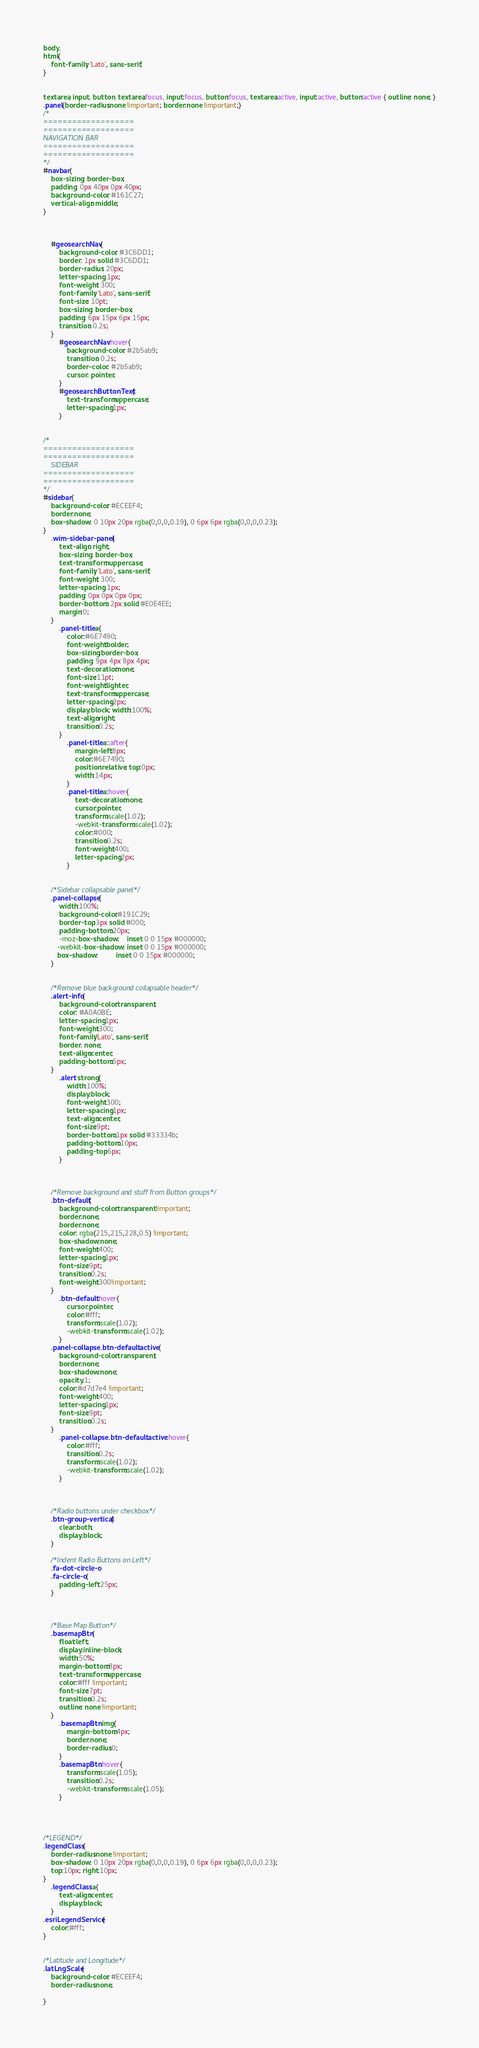<code> <loc_0><loc_0><loc_500><loc_500><_CSS_>body,
html{
    font-family: 'Lato', sans-serif;
}


textarea, input, button, textarea:focus, input:focus, button:focus, textarea:active, input:active, button:active { outline: none; }
.panel{border-radius:none !important; border:none !important;}
/*
===================
===================
NAVIGATION BAR
===================
===================
*/
#navbar{
    box-sizing: border-box;
    padding: 0px 40px 0px 40px;
    background-color: #161C27;
    vertical-align: middle;
}

    

    #geosearchNav{
        background-color: #3C6DD1;
        border: 1px solid #3C6DD1;
        border-radius: 20px;
        letter-spacing: 1px;
        font-weight: 300;
        font-family: 'Lato', sans-serif;
        font-size: 10pt;
        box-sizing: border-box;
        padding: 6px 15px 6px 15px;
        transition: 0.2s;
    }
        #geosearchNav:hover{
            background-color: #2b5ab9;
            transition: 0.2s;
            border-color: #2b5ab9;
            cursor: pointer;
        }
        #geosearchButtonText{
            text-transform:uppercase;
            letter-spacing:1px;
        }


/*
===================
===================
    SIDEBAR
===================
===================
*/
#sidebar{
    background-color: #ECEEF4;
    border:none;
    box-shadow: 0 10px 20px rgba(0,0,0,0.19), 0 6px 6px rgba(0,0,0,0.23);
}
    .wim-sidebar-panel{
        text-align: right;
        box-sizing: border-box;
        text-transform: uppercase;
        font-family: 'Lato', sans-serif;
        font-weight: 300;
        letter-spacing: 1px;
        padding: 0px 0px 0px 0px;
        border-bottom: 2px solid #E0E4EE;
        margin:0;
    }
        .panel-title a{
            color:#6E7490;
            font-weight:bolder;
            box-sizing:border-box;
            padding: 9px 4px 8px 4px;
            text-decoration:none;
            font-size:11pt;
            font-weight:lighter;
            text-transform:uppercase;
            letter-spacing:2px;
            display:block; width:100%;
            text-align:right;
            transition:0.2s;
        }
            .panel-title a::after{
                margin-left:8px;
                color:#6E7490;
                position:relative; top:0px;
                width:14px;
            }
            .panel-title a:hover{
                text-decoration:none;
                cursor:pointer;
                transform:scale(1.02);
                -webkit-transform:scale(1.02);
                color:#000;
                transition:0.2s;
                font-weight:400;
                letter-spacing:2px;
            }


    /*Sidebar collapsable panel*/
    .panel-collapse{
        width:100%;
        background-color:#191C29;
        border-top:3px solid #000;
        padding-bottom:20px;
        -moz-box-shadow:    inset 0 0 15px #000000;
       -webkit-box-shadow: inset 0 0 15px #000000;
       box-shadow:         inset 0 0 15px #000000;
    }


    /*Remove blue background collapsable header*/
    .alert-info{
        background-color:transparent;
        color: #A0A0BE;
        letter-spacing:1px;
        font-weight:300;
        font-family:'Lato', sans-serif;
        border: none;
        text-align:center;
        padding-bottom:5px;
    }
        .alert strong{
            width:100%;
            display:block;
            font-weight:300;
            letter-spacing:1px;
            text-align:center;
            font-size:9pt;
            border-bottom:1px solid #33334b;
            padding-bottom:10px;
            padding-top:6px;
        }



    /*Remove background and stuff from Button groups*/
    .btn-default{
        background-color:transparent !important;
        border:none;
        border:none;
        color: rgba(215,215,228,0.5) !important;
        box-shadow:none;
        font-weight:400;
        letter-spacing:1px;
        font-size:9pt;
        transition:0.2s;
        font-weight:300!important;
    }
        .btn-default:hover{
            cursor:pointer;
            color:#fff;
            transform:scale(1.02);
            -webkit-transform:scale(1.02);
        }
    .panel-collapse .btn-default.active{
        background-color:transparent;
        border:none;
        box-shadow:none;
        opacity:1;
        color:#d7d7e4 !important;
        font-weight:400;
        letter-spacing:1px;
        font-size:9pt;
        transition:0.2s;
    }
        .panel-collapse .btn-default.active:hover{
            color:#fff;
            transition:0.2s;
            transform:scale(1.02);
            -webkit-transform:scale(1.02);
        }



    /*Radio buttons under checkbox*/
    .btn-group-vertical{
        clear:both;
        display:block;
    }

    /*Indent Radio Buttons on Left*/
    .fa-dot-circle-o,
    .fa-circle-o{
        padding-left:25px;
    }



    /*Base Map Button*/
    .basemapBtn{
        float:left;
        display:inline-block;
        width:50%;
        margin-bottom:8px;
        text-transform:uppercase;
        color:#fff !important;
        font-size:7pt;
        transition:0.2s;
        outline: none !important;
    }
        .basemapBtn img{
            margin-bottom:4px;
            border:none;
            border-radius:0;
        }
        .basemapBtn:hover{
            transform:scale(1.05);
            transition:0.2s;
            -webkit-transform:scale(1.05);
        }




/*LEGEND*/
.legendClass{
    border-radius:none !important;
    box-shadow: 0 10px 20px rgba(0,0,0,0.19), 0 6px 6px rgba(0,0,0,0.23);
    top:10px; right:10px;
}
    .legendClass a{
        text-align:center;
        display:block;
    }
.esriLegendService{
    color:#fff;
}


/*Latitude and Longitude*/
.latLngScale{
    background-color: #ECEEF4;
    border-radius:none;

}</code> 